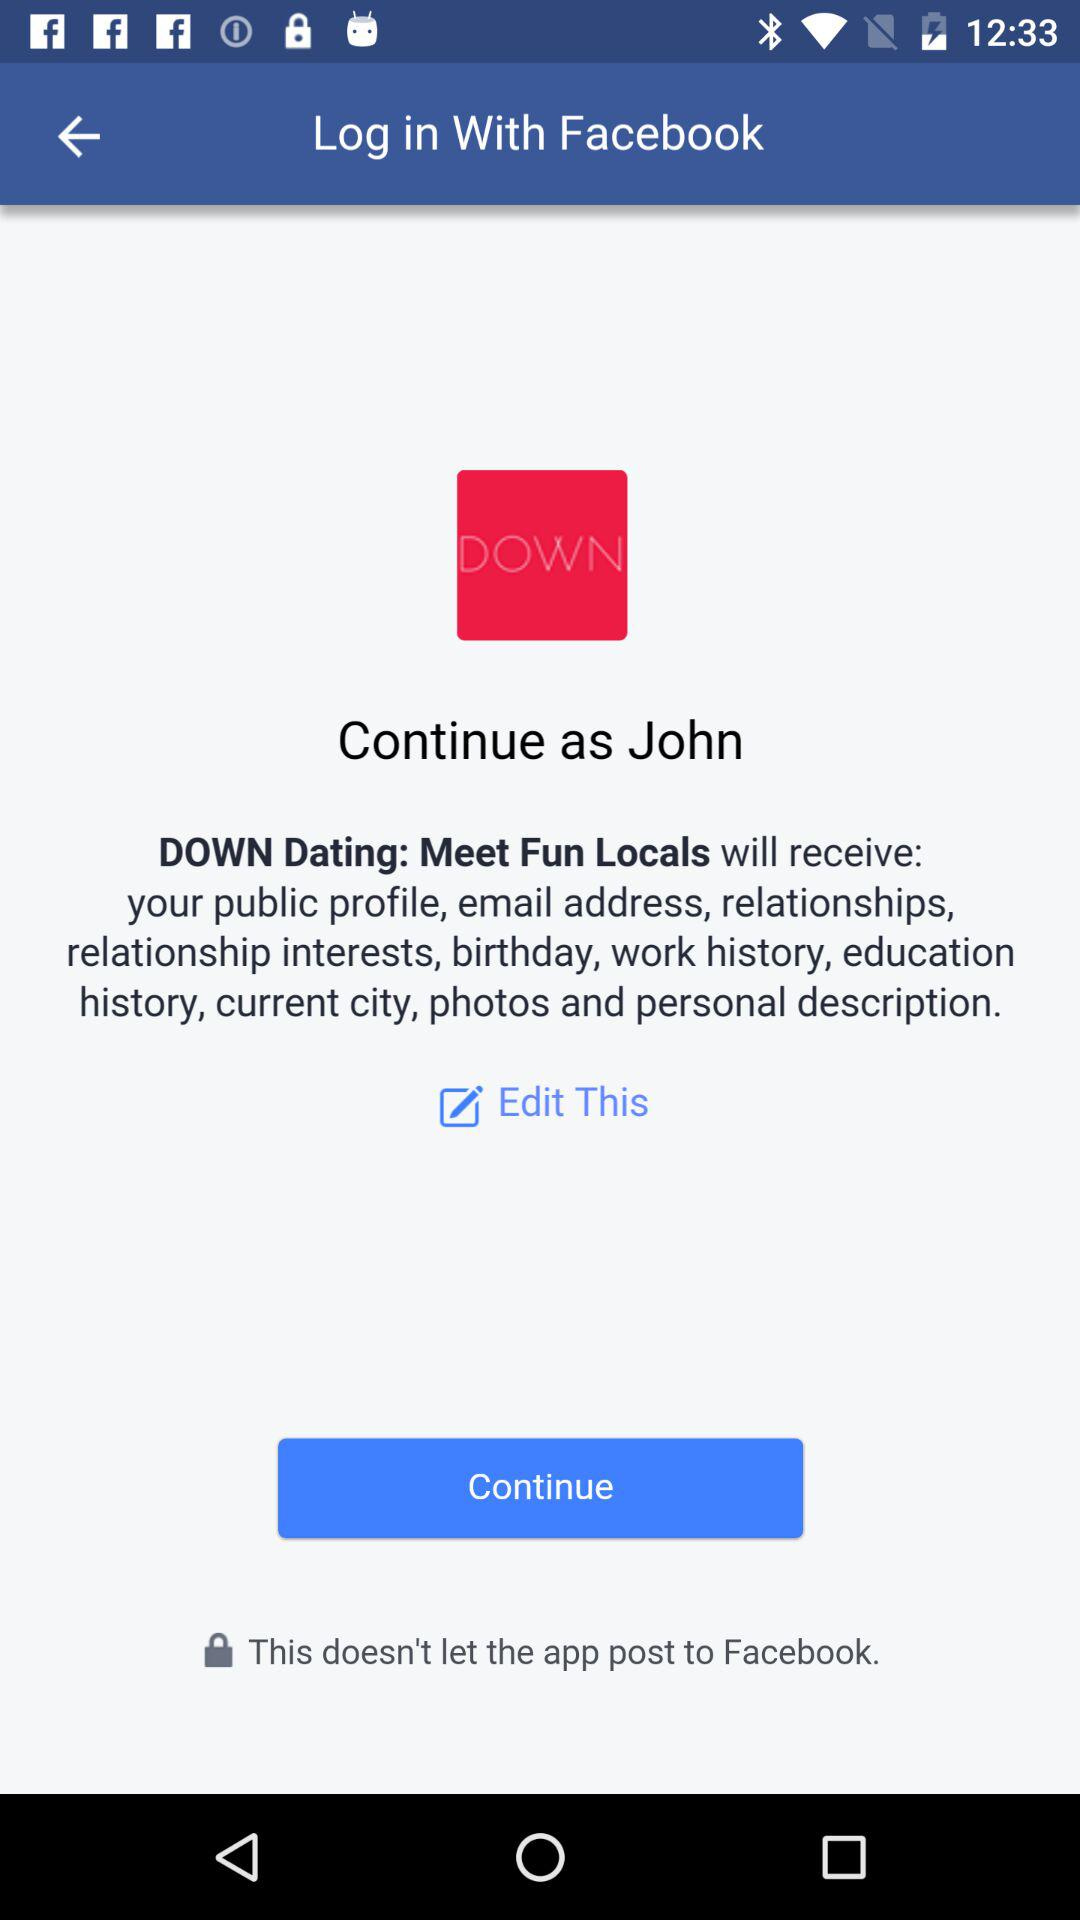Which information will the "DOWN Dating: Meet Fun Locals" application receive? The application will receive the public profile, email address, relationships, relationship interests, birthday, work history, education history, current city, photos and personal description. 